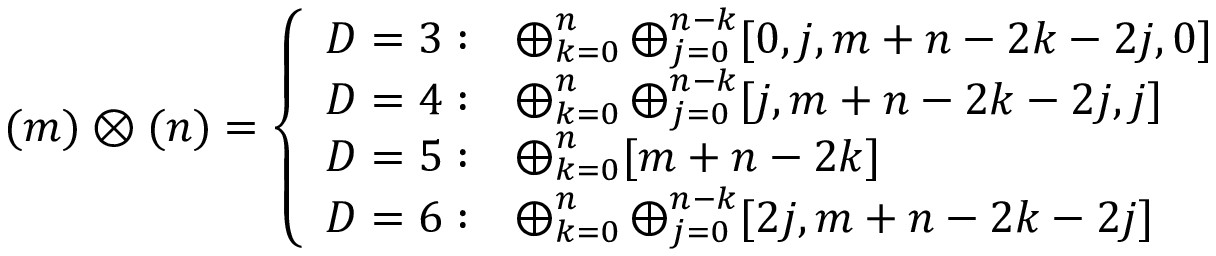<formula> <loc_0><loc_0><loc_500><loc_500>( m ) \otimes ( n ) = \left \{ \begin{array} { l l } { D = 3 \colon } & { { \bigoplus _ { k = 0 } ^ { n } \bigoplus _ { j = 0 } ^ { n - k } [ 0 , j , m + n - 2 k - 2 j , 0 ] } } \\ { D = 4 \colon } & { { \bigoplus _ { k = 0 } ^ { n } \bigoplus _ { j = 0 } ^ { n - k } [ j , m + n - 2 k - 2 j , j ] } } \\ { D = 5 \colon } & { { \bigoplus _ { k = 0 } ^ { n } [ m + n - 2 k ] } } \\ { D = 6 \colon } & { { \bigoplus _ { k = 0 } ^ { n } \bigoplus _ { j = 0 } ^ { n - k } [ 2 j , m + n - 2 k - 2 j ] } } \end{array}</formula> 